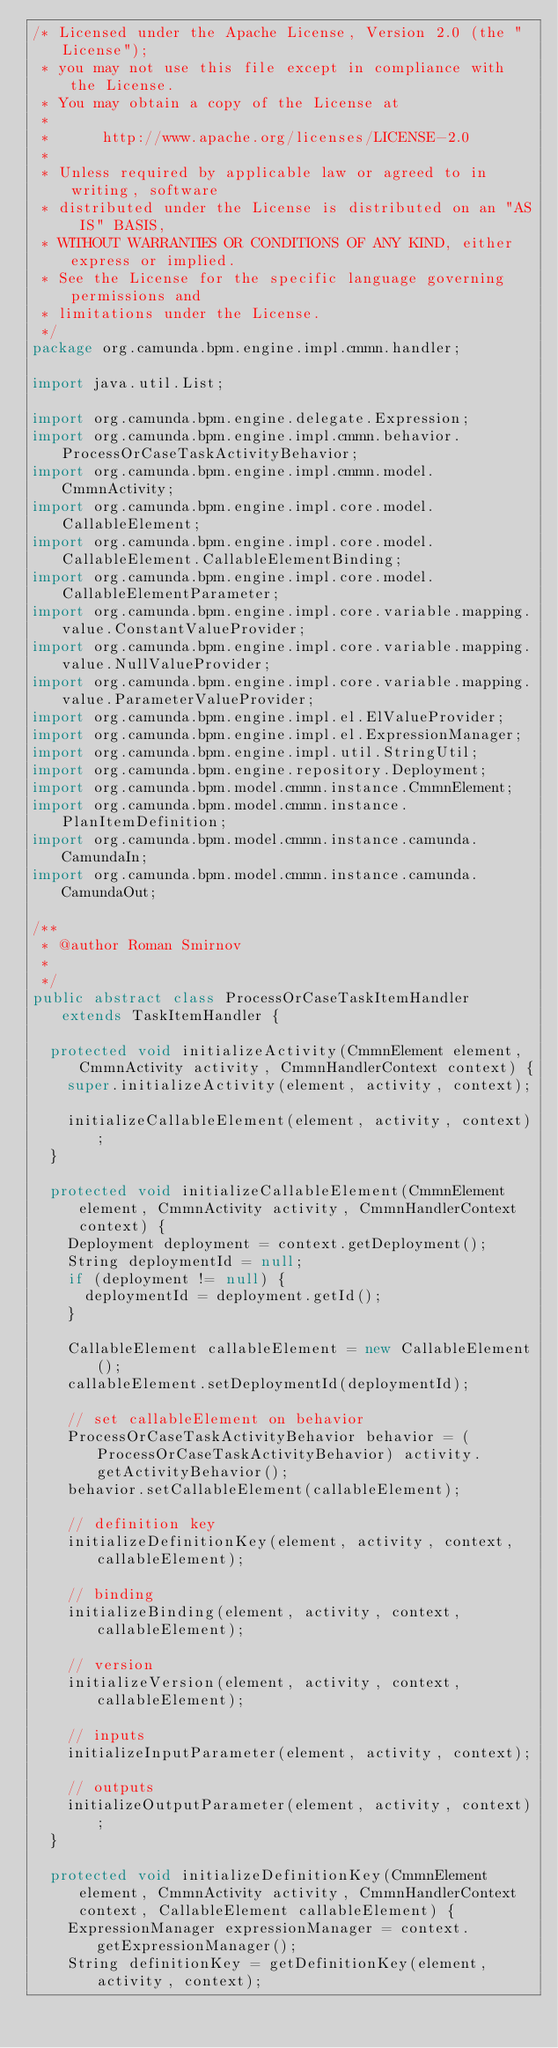Convert code to text. <code><loc_0><loc_0><loc_500><loc_500><_Java_>/* Licensed under the Apache License, Version 2.0 (the "License");
 * you may not use this file except in compliance with the License.
 * You may obtain a copy of the License at
 *
 *      http://www.apache.org/licenses/LICENSE-2.0
 *
 * Unless required by applicable law or agreed to in writing, software
 * distributed under the License is distributed on an "AS IS" BASIS,
 * WITHOUT WARRANTIES OR CONDITIONS OF ANY KIND, either express or implied.
 * See the License for the specific language governing permissions and
 * limitations under the License.
 */
package org.camunda.bpm.engine.impl.cmmn.handler;

import java.util.List;

import org.camunda.bpm.engine.delegate.Expression;
import org.camunda.bpm.engine.impl.cmmn.behavior.ProcessOrCaseTaskActivityBehavior;
import org.camunda.bpm.engine.impl.cmmn.model.CmmnActivity;
import org.camunda.bpm.engine.impl.core.model.CallableElement;
import org.camunda.bpm.engine.impl.core.model.CallableElement.CallableElementBinding;
import org.camunda.bpm.engine.impl.core.model.CallableElementParameter;
import org.camunda.bpm.engine.impl.core.variable.mapping.value.ConstantValueProvider;
import org.camunda.bpm.engine.impl.core.variable.mapping.value.NullValueProvider;
import org.camunda.bpm.engine.impl.core.variable.mapping.value.ParameterValueProvider;
import org.camunda.bpm.engine.impl.el.ElValueProvider;
import org.camunda.bpm.engine.impl.el.ExpressionManager;
import org.camunda.bpm.engine.impl.util.StringUtil;
import org.camunda.bpm.engine.repository.Deployment;
import org.camunda.bpm.model.cmmn.instance.CmmnElement;
import org.camunda.bpm.model.cmmn.instance.PlanItemDefinition;
import org.camunda.bpm.model.cmmn.instance.camunda.CamundaIn;
import org.camunda.bpm.model.cmmn.instance.camunda.CamundaOut;

/**
 * @author Roman Smirnov
 *
 */
public abstract class ProcessOrCaseTaskItemHandler extends TaskItemHandler {

  protected void initializeActivity(CmmnElement element, CmmnActivity activity, CmmnHandlerContext context) {
    super.initializeActivity(element, activity, context);

    initializeCallableElement(element, activity, context);
  }

  protected void initializeCallableElement(CmmnElement element, CmmnActivity activity, CmmnHandlerContext context) {
    Deployment deployment = context.getDeployment();
    String deploymentId = null;
    if (deployment != null) {
      deploymentId = deployment.getId();
    }

    CallableElement callableElement = new CallableElement();
    callableElement.setDeploymentId(deploymentId);

    // set callableElement on behavior
    ProcessOrCaseTaskActivityBehavior behavior = (ProcessOrCaseTaskActivityBehavior) activity.getActivityBehavior();
    behavior.setCallableElement(callableElement);

    // definition key
    initializeDefinitionKey(element, activity, context, callableElement);

    // binding
    initializeBinding(element, activity, context, callableElement);

    // version
    initializeVersion(element, activity, context, callableElement);

    // inputs
    initializeInputParameter(element, activity, context);

    // outputs
    initializeOutputParameter(element, activity, context);
  }

  protected void initializeDefinitionKey(CmmnElement element, CmmnActivity activity, CmmnHandlerContext context, CallableElement callableElement) {
    ExpressionManager expressionManager = context.getExpressionManager();
    String definitionKey = getDefinitionKey(element, activity, context);</code> 